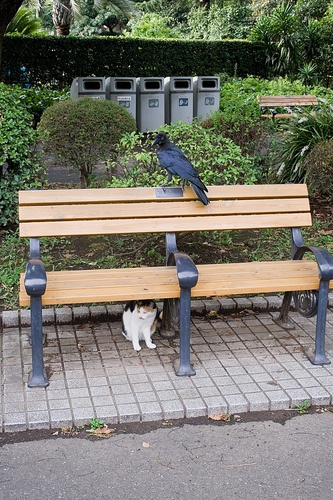Describe the objects in this image and their specific colors. I can see bench in black, tan, lightgray, and gray tones, bird in black, gray, and darkblue tones, cat in black, lightgray, darkgray, and gray tones, and bench in black, darkgray, tan, and gray tones in this image. 